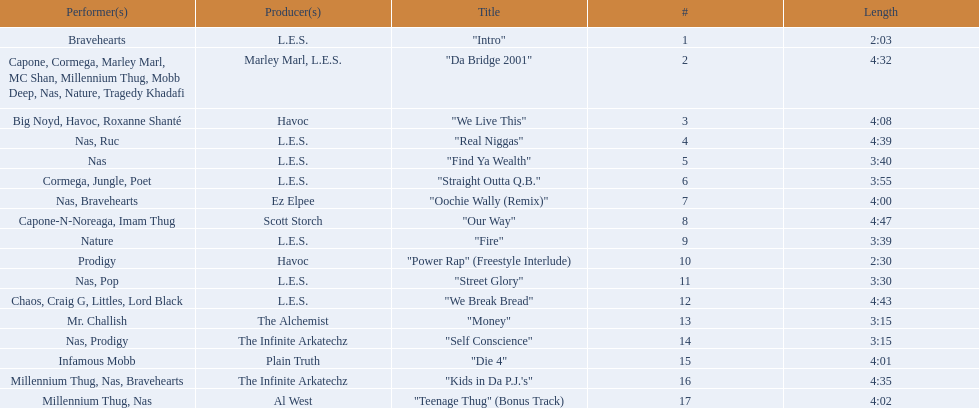What are the track times on the nas & ill will records presents qb's finest album? 2:03, 4:32, 4:08, 4:39, 3:40, 3:55, 4:00, 4:47, 3:39, 2:30, 3:30, 4:43, 3:15, 3:15, 4:01, 4:35, 4:02. Of those which is the longest? 4:47. 